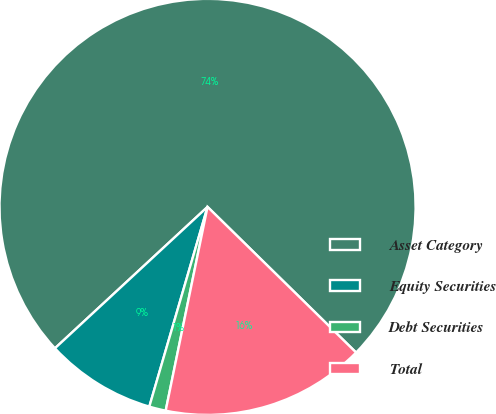Convert chart to OTSL. <chart><loc_0><loc_0><loc_500><loc_500><pie_chart><fcel>Asset Category<fcel>Equity Securities<fcel>Debt Securities<fcel>Total<nl><fcel>74.23%<fcel>8.59%<fcel>1.29%<fcel>15.88%<nl></chart> 